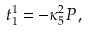<formula> <loc_0><loc_0><loc_500><loc_500>t ^ { 1 } _ { 1 } = - \kappa _ { 5 } ^ { 2 } P \, ,</formula> 